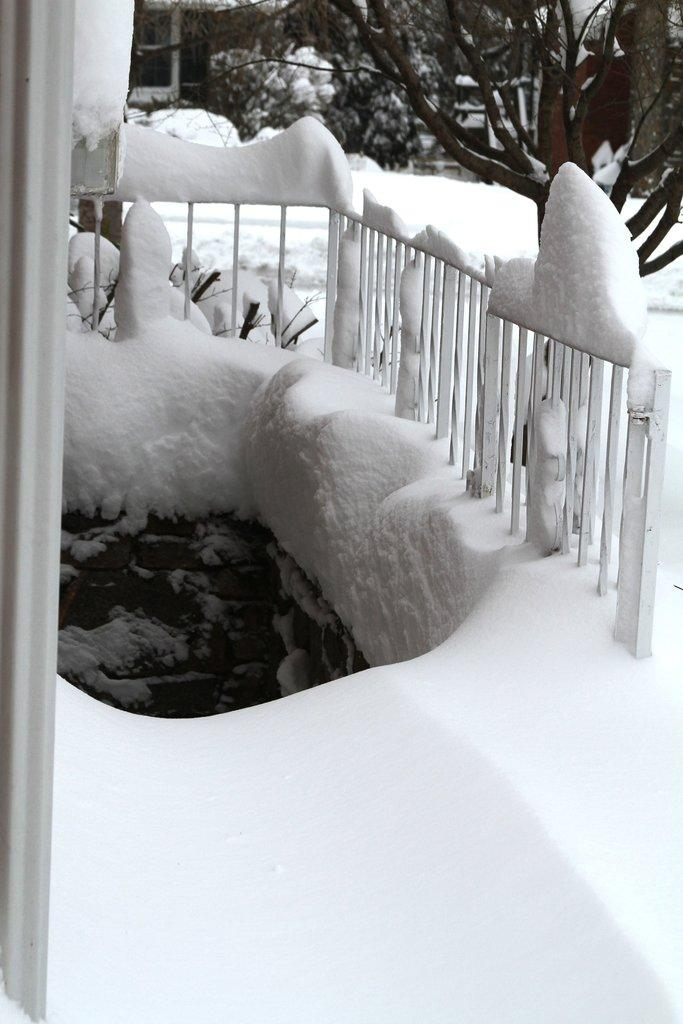What can be seen on the right side of the image? There is a boundary on the right side of the image. What is the ground condition in the image? There is snow around the area of the image. What type of vegetation is visible at the top side of the image? There are trees at the top side of the image. How many jellyfish can be seen swimming in the snow in the image? There are no jellyfish present in the image; it features a boundary, snow, and trees. What is the distance between the trees and the boundary in the image? The provided facts do not give information about the distance between the trees and the boundary, so it cannot be determined from the image. 